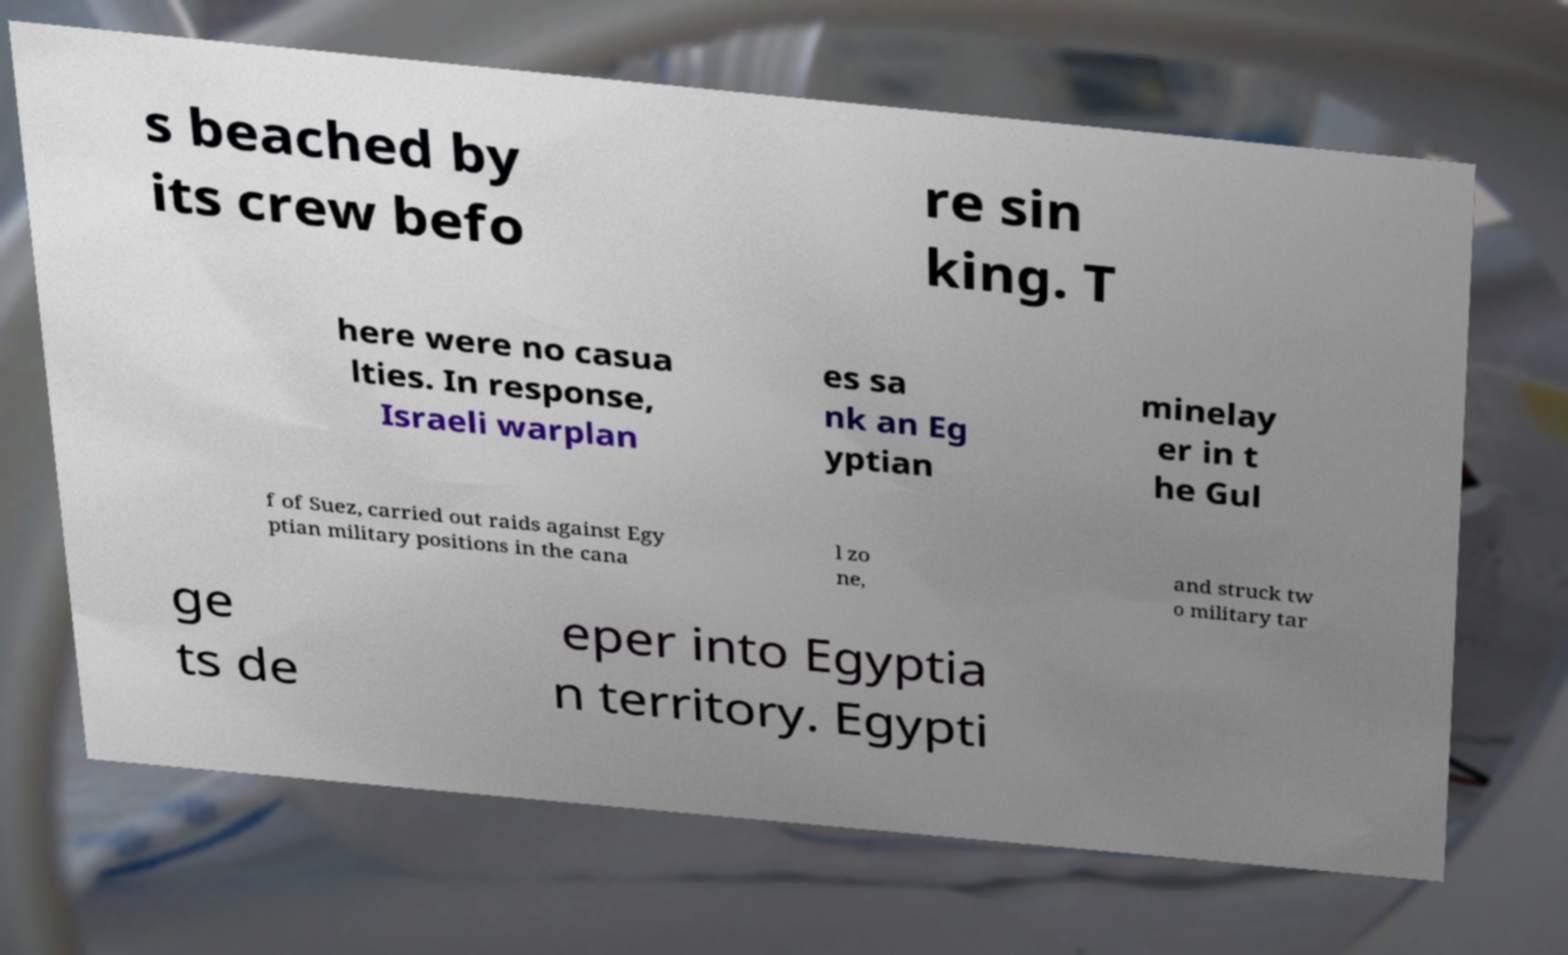Could you extract and type out the text from this image? s beached by its crew befo re sin king. T here were no casua lties. In response, Israeli warplan es sa nk an Eg yptian minelay er in t he Gul f of Suez, carried out raids against Egy ptian military positions in the cana l zo ne, and struck tw o military tar ge ts de eper into Egyptia n territory. Egypti 